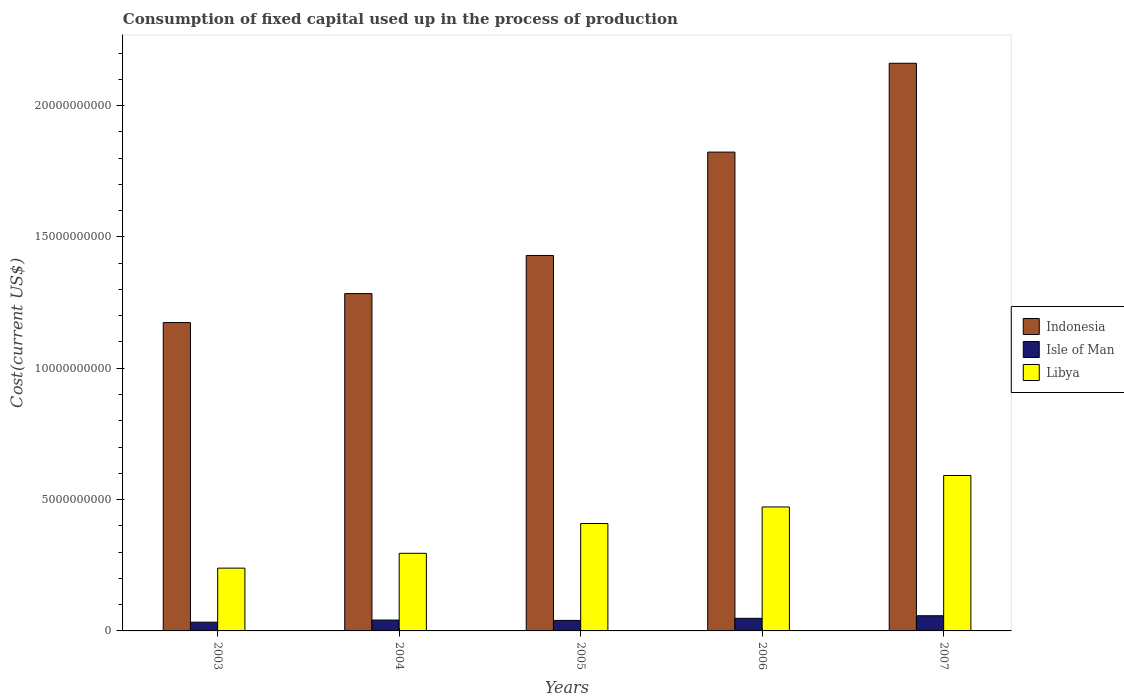How many different coloured bars are there?
Provide a succinct answer. 3. Are the number of bars per tick equal to the number of legend labels?
Keep it short and to the point. Yes. Are the number of bars on each tick of the X-axis equal?
Give a very brief answer. Yes. In how many cases, is the number of bars for a given year not equal to the number of legend labels?
Ensure brevity in your answer.  0. What is the amount consumed in the process of production in Indonesia in 2007?
Provide a succinct answer. 2.16e+1. Across all years, what is the maximum amount consumed in the process of production in Isle of Man?
Your response must be concise. 5.78e+08. Across all years, what is the minimum amount consumed in the process of production in Libya?
Make the answer very short. 2.39e+09. In which year was the amount consumed in the process of production in Isle of Man minimum?
Ensure brevity in your answer.  2003. What is the total amount consumed in the process of production in Libya in the graph?
Your response must be concise. 2.01e+1. What is the difference between the amount consumed in the process of production in Libya in 2006 and that in 2007?
Provide a short and direct response. -1.20e+09. What is the difference between the amount consumed in the process of production in Indonesia in 2007 and the amount consumed in the process of production in Libya in 2006?
Give a very brief answer. 1.69e+1. What is the average amount consumed in the process of production in Isle of Man per year?
Keep it short and to the point. 4.41e+08. In the year 2007, what is the difference between the amount consumed in the process of production in Libya and amount consumed in the process of production in Indonesia?
Give a very brief answer. -1.57e+1. In how many years, is the amount consumed in the process of production in Isle of Man greater than 17000000000 US$?
Provide a short and direct response. 0. What is the ratio of the amount consumed in the process of production in Libya in 2003 to that in 2004?
Your response must be concise. 0.81. Is the amount consumed in the process of production in Indonesia in 2004 less than that in 2005?
Your answer should be compact. Yes. What is the difference between the highest and the second highest amount consumed in the process of production in Indonesia?
Your answer should be very brief. 3.38e+09. What is the difference between the highest and the lowest amount consumed in the process of production in Isle of Man?
Offer a terse response. 2.46e+08. In how many years, is the amount consumed in the process of production in Libya greater than the average amount consumed in the process of production in Libya taken over all years?
Offer a terse response. 3. Is the sum of the amount consumed in the process of production in Libya in 2003 and 2006 greater than the maximum amount consumed in the process of production in Indonesia across all years?
Offer a very short reply. No. What does the 2nd bar from the left in 2003 represents?
Ensure brevity in your answer.  Isle of Man. What does the 3rd bar from the right in 2005 represents?
Your answer should be very brief. Indonesia. Is it the case that in every year, the sum of the amount consumed in the process of production in Indonesia and amount consumed in the process of production in Libya is greater than the amount consumed in the process of production in Isle of Man?
Make the answer very short. Yes. Are all the bars in the graph horizontal?
Your response must be concise. No. What is the difference between two consecutive major ticks on the Y-axis?
Keep it short and to the point. 5.00e+09. Are the values on the major ticks of Y-axis written in scientific E-notation?
Offer a very short reply. No. Does the graph contain any zero values?
Provide a short and direct response. No. How many legend labels are there?
Provide a succinct answer. 3. How are the legend labels stacked?
Offer a terse response. Vertical. What is the title of the graph?
Offer a terse response. Consumption of fixed capital used up in the process of production. What is the label or title of the Y-axis?
Provide a succinct answer. Cost(current US$). What is the Cost(current US$) in Indonesia in 2003?
Offer a very short reply. 1.17e+1. What is the Cost(current US$) of Isle of Man in 2003?
Keep it short and to the point. 3.33e+08. What is the Cost(current US$) of Libya in 2003?
Your answer should be very brief. 2.39e+09. What is the Cost(current US$) of Indonesia in 2004?
Keep it short and to the point. 1.28e+1. What is the Cost(current US$) in Isle of Man in 2004?
Provide a succinct answer. 4.14e+08. What is the Cost(current US$) of Libya in 2004?
Offer a terse response. 2.96e+09. What is the Cost(current US$) of Indonesia in 2005?
Your answer should be compact. 1.43e+1. What is the Cost(current US$) in Isle of Man in 2005?
Make the answer very short. 4.00e+08. What is the Cost(current US$) of Libya in 2005?
Provide a succinct answer. 4.09e+09. What is the Cost(current US$) in Indonesia in 2006?
Offer a very short reply. 1.82e+1. What is the Cost(current US$) of Isle of Man in 2006?
Keep it short and to the point. 4.79e+08. What is the Cost(current US$) of Libya in 2006?
Make the answer very short. 4.72e+09. What is the Cost(current US$) in Indonesia in 2007?
Your response must be concise. 2.16e+1. What is the Cost(current US$) in Isle of Man in 2007?
Offer a terse response. 5.78e+08. What is the Cost(current US$) in Libya in 2007?
Ensure brevity in your answer.  5.92e+09. Across all years, what is the maximum Cost(current US$) in Indonesia?
Offer a terse response. 2.16e+1. Across all years, what is the maximum Cost(current US$) of Isle of Man?
Your response must be concise. 5.78e+08. Across all years, what is the maximum Cost(current US$) of Libya?
Provide a succinct answer. 5.92e+09. Across all years, what is the minimum Cost(current US$) in Indonesia?
Ensure brevity in your answer.  1.17e+1. Across all years, what is the minimum Cost(current US$) of Isle of Man?
Offer a very short reply. 3.33e+08. Across all years, what is the minimum Cost(current US$) in Libya?
Give a very brief answer. 2.39e+09. What is the total Cost(current US$) in Indonesia in the graph?
Provide a succinct answer. 7.87e+1. What is the total Cost(current US$) of Isle of Man in the graph?
Your answer should be very brief. 2.20e+09. What is the total Cost(current US$) in Libya in the graph?
Your answer should be very brief. 2.01e+1. What is the difference between the Cost(current US$) of Indonesia in 2003 and that in 2004?
Give a very brief answer. -1.10e+09. What is the difference between the Cost(current US$) in Isle of Man in 2003 and that in 2004?
Provide a short and direct response. -8.08e+07. What is the difference between the Cost(current US$) in Libya in 2003 and that in 2004?
Keep it short and to the point. -5.65e+08. What is the difference between the Cost(current US$) of Indonesia in 2003 and that in 2005?
Offer a very short reply. -2.55e+09. What is the difference between the Cost(current US$) in Isle of Man in 2003 and that in 2005?
Ensure brevity in your answer.  -6.71e+07. What is the difference between the Cost(current US$) in Libya in 2003 and that in 2005?
Provide a short and direct response. -1.70e+09. What is the difference between the Cost(current US$) in Indonesia in 2003 and that in 2006?
Give a very brief answer. -6.49e+09. What is the difference between the Cost(current US$) of Isle of Man in 2003 and that in 2006?
Ensure brevity in your answer.  -1.47e+08. What is the difference between the Cost(current US$) in Libya in 2003 and that in 2006?
Offer a terse response. -2.33e+09. What is the difference between the Cost(current US$) of Indonesia in 2003 and that in 2007?
Provide a short and direct response. -9.87e+09. What is the difference between the Cost(current US$) of Isle of Man in 2003 and that in 2007?
Provide a short and direct response. -2.46e+08. What is the difference between the Cost(current US$) of Libya in 2003 and that in 2007?
Provide a short and direct response. -3.53e+09. What is the difference between the Cost(current US$) in Indonesia in 2004 and that in 2005?
Ensure brevity in your answer.  -1.45e+09. What is the difference between the Cost(current US$) in Isle of Man in 2004 and that in 2005?
Your answer should be very brief. 1.37e+07. What is the difference between the Cost(current US$) of Libya in 2004 and that in 2005?
Offer a terse response. -1.13e+09. What is the difference between the Cost(current US$) of Indonesia in 2004 and that in 2006?
Your response must be concise. -5.39e+09. What is the difference between the Cost(current US$) of Isle of Man in 2004 and that in 2006?
Your response must be concise. -6.58e+07. What is the difference between the Cost(current US$) of Libya in 2004 and that in 2006?
Your response must be concise. -1.76e+09. What is the difference between the Cost(current US$) of Indonesia in 2004 and that in 2007?
Keep it short and to the point. -8.77e+09. What is the difference between the Cost(current US$) of Isle of Man in 2004 and that in 2007?
Provide a succinct answer. -1.65e+08. What is the difference between the Cost(current US$) in Libya in 2004 and that in 2007?
Your response must be concise. -2.96e+09. What is the difference between the Cost(current US$) in Indonesia in 2005 and that in 2006?
Ensure brevity in your answer.  -3.94e+09. What is the difference between the Cost(current US$) in Isle of Man in 2005 and that in 2006?
Make the answer very short. -7.96e+07. What is the difference between the Cost(current US$) of Libya in 2005 and that in 2006?
Make the answer very short. -6.31e+08. What is the difference between the Cost(current US$) in Indonesia in 2005 and that in 2007?
Provide a succinct answer. -7.32e+09. What is the difference between the Cost(current US$) of Isle of Man in 2005 and that in 2007?
Give a very brief answer. -1.78e+08. What is the difference between the Cost(current US$) of Libya in 2005 and that in 2007?
Provide a short and direct response. -1.83e+09. What is the difference between the Cost(current US$) of Indonesia in 2006 and that in 2007?
Ensure brevity in your answer.  -3.38e+09. What is the difference between the Cost(current US$) of Isle of Man in 2006 and that in 2007?
Offer a terse response. -9.89e+07. What is the difference between the Cost(current US$) in Libya in 2006 and that in 2007?
Give a very brief answer. -1.20e+09. What is the difference between the Cost(current US$) of Indonesia in 2003 and the Cost(current US$) of Isle of Man in 2004?
Your response must be concise. 1.13e+1. What is the difference between the Cost(current US$) in Indonesia in 2003 and the Cost(current US$) in Libya in 2004?
Your response must be concise. 8.78e+09. What is the difference between the Cost(current US$) in Isle of Man in 2003 and the Cost(current US$) in Libya in 2004?
Make the answer very short. -2.62e+09. What is the difference between the Cost(current US$) in Indonesia in 2003 and the Cost(current US$) in Isle of Man in 2005?
Offer a very short reply. 1.13e+1. What is the difference between the Cost(current US$) of Indonesia in 2003 and the Cost(current US$) of Libya in 2005?
Your response must be concise. 7.65e+09. What is the difference between the Cost(current US$) of Isle of Man in 2003 and the Cost(current US$) of Libya in 2005?
Make the answer very short. -3.76e+09. What is the difference between the Cost(current US$) in Indonesia in 2003 and the Cost(current US$) in Isle of Man in 2006?
Provide a succinct answer. 1.13e+1. What is the difference between the Cost(current US$) in Indonesia in 2003 and the Cost(current US$) in Libya in 2006?
Keep it short and to the point. 7.02e+09. What is the difference between the Cost(current US$) of Isle of Man in 2003 and the Cost(current US$) of Libya in 2006?
Your answer should be very brief. -4.39e+09. What is the difference between the Cost(current US$) of Indonesia in 2003 and the Cost(current US$) of Isle of Man in 2007?
Make the answer very short. 1.12e+1. What is the difference between the Cost(current US$) in Indonesia in 2003 and the Cost(current US$) in Libya in 2007?
Give a very brief answer. 5.82e+09. What is the difference between the Cost(current US$) of Isle of Man in 2003 and the Cost(current US$) of Libya in 2007?
Keep it short and to the point. -5.58e+09. What is the difference between the Cost(current US$) of Indonesia in 2004 and the Cost(current US$) of Isle of Man in 2005?
Give a very brief answer. 1.24e+1. What is the difference between the Cost(current US$) in Indonesia in 2004 and the Cost(current US$) in Libya in 2005?
Keep it short and to the point. 8.75e+09. What is the difference between the Cost(current US$) in Isle of Man in 2004 and the Cost(current US$) in Libya in 2005?
Offer a very short reply. -3.68e+09. What is the difference between the Cost(current US$) of Indonesia in 2004 and the Cost(current US$) of Isle of Man in 2006?
Your answer should be compact. 1.24e+1. What is the difference between the Cost(current US$) of Indonesia in 2004 and the Cost(current US$) of Libya in 2006?
Offer a terse response. 8.12e+09. What is the difference between the Cost(current US$) in Isle of Man in 2004 and the Cost(current US$) in Libya in 2006?
Ensure brevity in your answer.  -4.31e+09. What is the difference between the Cost(current US$) of Indonesia in 2004 and the Cost(current US$) of Isle of Man in 2007?
Your answer should be very brief. 1.23e+1. What is the difference between the Cost(current US$) in Indonesia in 2004 and the Cost(current US$) in Libya in 2007?
Offer a terse response. 6.92e+09. What is the difference between the Cost(current US$) of Isle of Man in 2004 and the Cost(current US$) of Libya in 2007?
Offer a terse response. -5.50e+09. What is the difference between the Cost(current US$) in Indonesia in 2005 and the Cost(current US$) in Isle of Man in 2006?
Your answer should be compact. 1.38e+1. What is the difference between the Cost(current US$) of Indonesia in 2005 and the Cost(current US$) of Libya in 2006?
Give a very brief answer. 9.57e+09. What is the difference between the Cost(current US$) in Isle of Man in 2005 and the Cost(current US$) in Libya in 2006?
Your answer should be compact. -4.32e+09. What is the difference between the Cost(current US$) of Indonesia in 2005 and the Cost(current US$) of Isle of Man in 2007?
Your answer should be compact. 1.37e+1. What is the difference between the Cost(current US$) of Indonesia in 2005 and the Cost(current US$) of Libya in 2007?
Offer a terse response. 8.38e+09. What is the difference between the Cost(current US$) of Isle of Man in 2005 and the Cost(current US$) of Libya in 2007?
Give a very brief answer. -5.52e+09. What is the difference between the Cost(current US$) of Indonesia in 2006 and the Cost(current US$) of Isle of Man in 2007?
Offer a very short reply. 1.77e+1. What is the difference between the Cost(current US$) of Indonesia in 2006 and the Cost(current US$) of Libya in 2007?
Keep it short and to the point. 1.23e+1. What is the difference between the Cost(current US$) of Isle of Man in 2006 and the Cost(current US$) of Libya in 2007?
Offer a very short reply. -5.44e+09. What is the average Cost(current US$) of Indonesia per year?
Provide a short and direct response. 1.57e+1. What is the average Cost(current US$) in Isle of Man per year?
Offer a terse response. 4.41e+08. What is the average Cost(current US$) in Libya per year?
Provide a succinct answer. 4.01e+09. In the year 2003, what is the difference between the Cost(current US$) of Indonesia and Cost(current US$) of Isle of Man?
Ensure brevity in your answer.  1.14e+1. In the year 2003, what is the difference between the Cost(current US$) in Indonesia and Cost(current US$) in Libya?
Provide a succinct answer. 9.35e+09. In the year 2003, what is the difference between the Cost(current US$) of Isle of Man and Cost(current US$) of Libya?
Provide a succinct answer. -2.06e+09. In the year 2004, what is the difference between the Cost(current US$) in Indonesia and Cost(current US$) in Isle of Man?
Keep it short and to the point. 1.24e+1. In the year 2004, what is the difference between the Cost(current US$) of Indonesia and Cost(current US$) of Libya?
Your answer should be compact. 9.89e+09. In the year 2004, what is the difference between the Cost(current US$) in Isle of Man and Cost(current US$) in Libya?
Your answer should be very brief. -2.54e+09. In the year 2005, what is the difference between the Cost(current US$) in Indonesia and Cost(current US$) in Isle of Man?
Make the answer very short. 1.39e+1. In the year 2005, what is the difference between the Cost(current US$) in Indonesia and Cost(current US$) in Libya?
Provide a short and direct response. 1.02e+1. In the year 2005, what is the difference between the Cost(current US$) of Isle of Man and Cost(current US$) of Libya?
Keep it short and to the point. -3.69e+09. In the year 2006, what is the difference between the Cost(current US$) of Indonesia and Cost(current US$) of Isle of Man?
Your answer should be compact. 1.77e+1. In the year 2006, what is the difference between the Cost(current US$) of Indonesia and Cost(current US$) of Libya?
Provide a succinct answer. 1.35e+1. In the year 2006, what is the difference between the Cost(current US$) of Isle of Man and Cost(current US$) of Libya?
Offer a very short reply. -4.24e+09. In the year 2007, what is the difference between the Cost(current US$) in Indonesia and Cost(current US$) in Isle of Man?
Provide a succinct answer. 2.10e+1. In the year 2007, what is the difference between the Cost(current US$) in Indonesia and Cost(current US$) in Libya?
Your answer should be very brief. 1.57e+1. In the year 2007, what is the difference between the Cost(current US$) in Isle of Man and Cost(current US$) in Libya?
Ensure brevity in your answer.  -5.34e+09. What is the ratio of the Cost(current US$) of Indonesia in 2003 to that in 2004?
Offer a terse response. 0.91. What is the ratio of the Cost(current US$) of Isle of Man in 2003 to that in 2004?
Ensure brevity in your answer.  0.8. What is the ratio of the Cost(current US$) of Libya in 2003 to that in 2004?
Offer a very short reply. 0.81. What is the ratio of the Cost(current US$) in Indonesia in 2003 to that in 2005?
Offer a terse response. 0.82. What is the ratio of the Cost(current US$) of Isle of Man in 2003 to that in 2005?
Provide a short and direct response. 0.83. What is the ratio of the Cost(current US$) in Libya in 2003 to that in 2005?
Provide a short and direct response. 0.58. What is the ratio of the Cost(current US$) of Indonesia in 2003 to that in 2006?
Offer a terse response. 0.64. What is the ratio of the Cost(current US$) in Isle of Man in 2003 to that in 2006?
Keep it short and to the point. 0.69. What is the ratio of the Cost(current US$) in Libya in 2003 to that in 2006?
Make the answer very short. 0.51. What is the ratio of the Cost(current US$) in Indonesia in 2003 to that in 2007?
Provide a succinct answer. 0.54. What is the ratio of the Cost(current US$) in Isle of Man in 2003 to that in 2007?
Ensure brevity in your answer.  0.58. What is the ratio of the Cost(current US$) in Libya in 2003 to that in 2007?
Keep it short and to the point. 0.4. What is the ratio of the Cost(current US$) in Indonesia in 2004 to that in 2005?
Make the answer very short. 0.9. What is the ratio of the Cost(current US$) in Isle of Man in 2004 to that in 2005?
Your answer should be very brief. 1.03. What is the ratio of the Cost(current US$) in Libya in 2004 to that in 2005?
Give a very brief answer. 0.72. What is the ratio of the Cost(current US$) in Indonesia in 2004 to that in 2006?
Provide a short and direct response. 0.7. What is the ratio of the Cost(current US$) of Isle of Man in 2004 to that in 2006?
Ensure brevity in your answer.  0.86. What is the ratio of the Cost(current US$) in Libya in 2004 to that in 2006?
Your answer should be compact. 0.63. What is the ratio of the Cost(current US$) in Indonesia in 2004 to that in 2007?
Keep it short and to the point. 0.59. What is the ratio of the Cost(current US$) of Isle of Man in 2004 to that in 2007?
Offer a very short reply. 0.72. What is the ratio of the Cost(current US$) of Libya in 2004 to that in 2007?
Your answer should be compact. 0.5. What is the ratio of the Cost(current US$) in Indonesia in 2005 to that in 2006?
Your answer should be very brief. 0.78. What is the ratio of the Cost(current US$) in Isle of Man in 2005 to that in 2006?
Provide a short and direct response. 0.83. What is the ratio of the Cost(current US$) of Libya in 2005 to that in 2006?
Your answer should be compact. 0.87. What is the ratio of the Cost(current US$) in Indonesia in 2005 to that in 2007?
Make the answer very short. 0.66. What is the ratio of the Cost(current US$) in Isle of Man in 2005 to that in 2007?
Your answer should be very brief. 0.69. What is the ratio of the Cost(current US$) in Libya in 2005 to that in 2007?
Offer a very short reply. 0.69. What is the ratio of the Cost(current US$) in Indonesia in 2006 to that in 2007?
Ensure brevity in your answer.  0.84. What is the ratio of the Cost(current US$) of Isle of Man in 2006 to that in 2007?
Keep it short and to the point. 0.83. What is the ratio of the Cost(current US$) in Libya in 2006 to that in 2007?
Provide a succinct answer. 0.8. What is the difference between the highest and the second highest Cost(current US$) in Indonesia?
Your response must be concise. 3.38e+09. What is the difference between the highest and the second highest Cost(current US$) of Isle of Man?
Provide a short and direct response. 9.89e+07. What is the difference between the highest and the second highest Cost(current US$) of Libya?
Offer a very short reply. 1.20e+09. What is the difference between the highest and the lowest Cost(current US$) in Indonesia?
Offer a terse response. 9.87e+09. What is the difference between the highest and the lowest Cost(current US$) in Isle of Man?
Offer a terse response. 2.46e+08. What is the difference between the highest and the lowest Cost(current US$) of Libya?
Keep it short and to the point. 3.53e+09. 